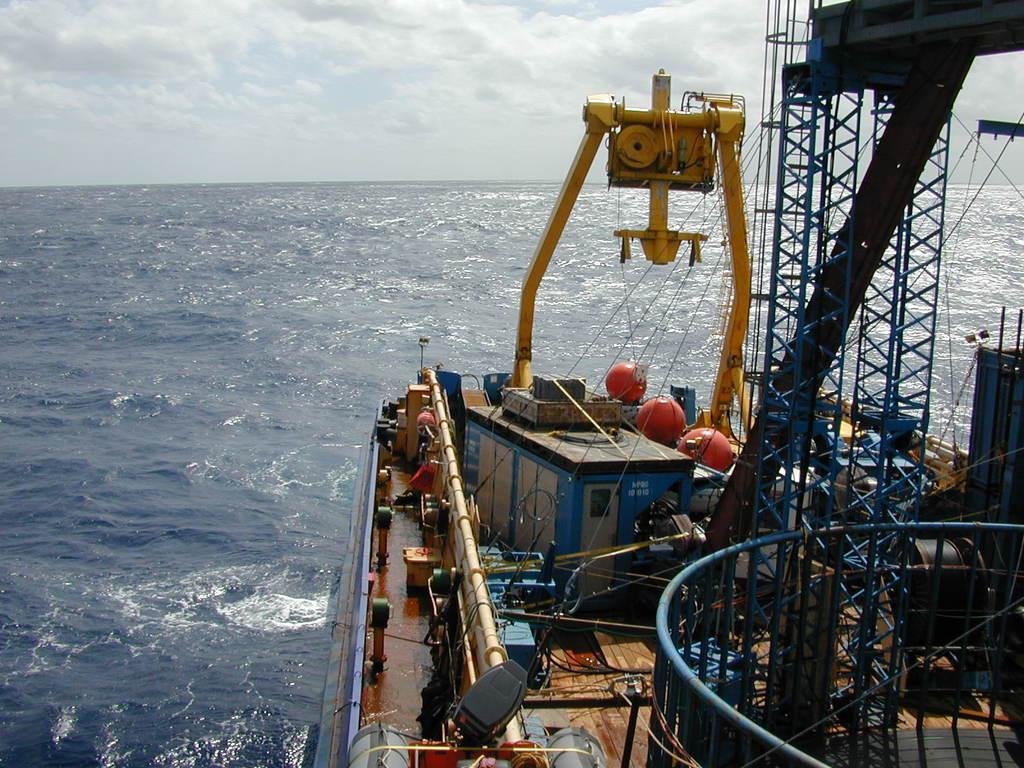Describe this image in one or two sentences. In the picture I can see the deck of a ship in the water. On the deck I can see the container, a mechanical machine and metal scaffolding structures. There are clouds in the sky. 